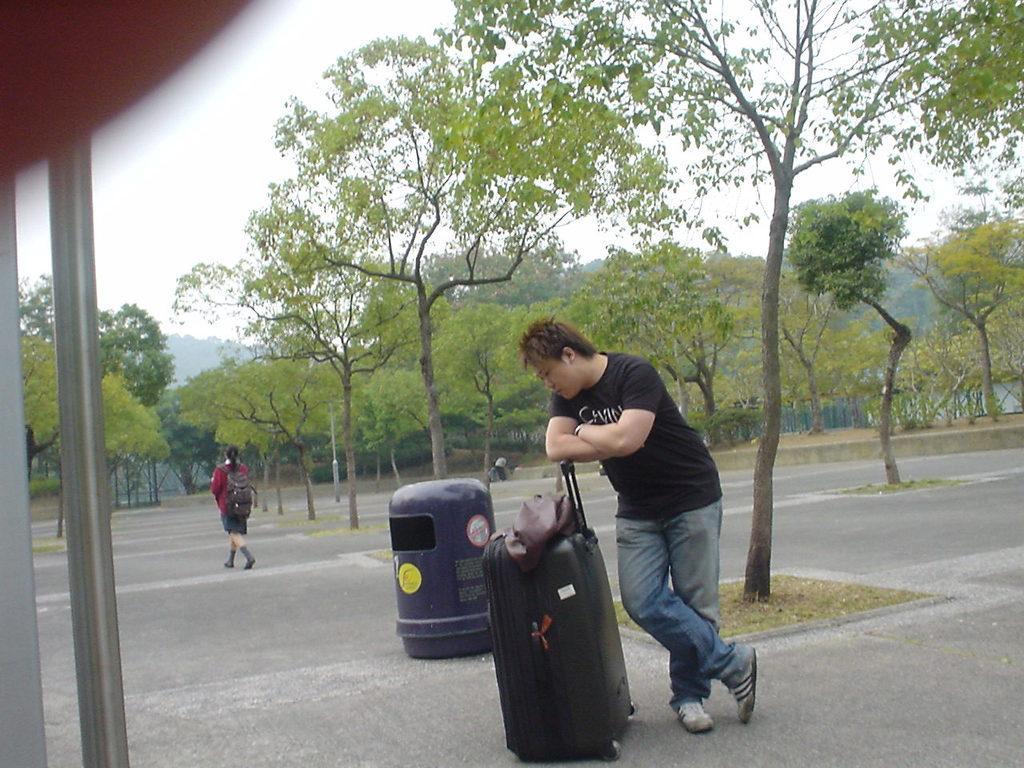In one or two sentences, can you explain what this image depicts? In the foreground of the picture there is man wearing black color T-shirt, blue color jeans standing, we can see luggage bag, there is dustbin and in the background of the picture there is woman walking along the road, there are some trees and top of the picture there is clear sky. 